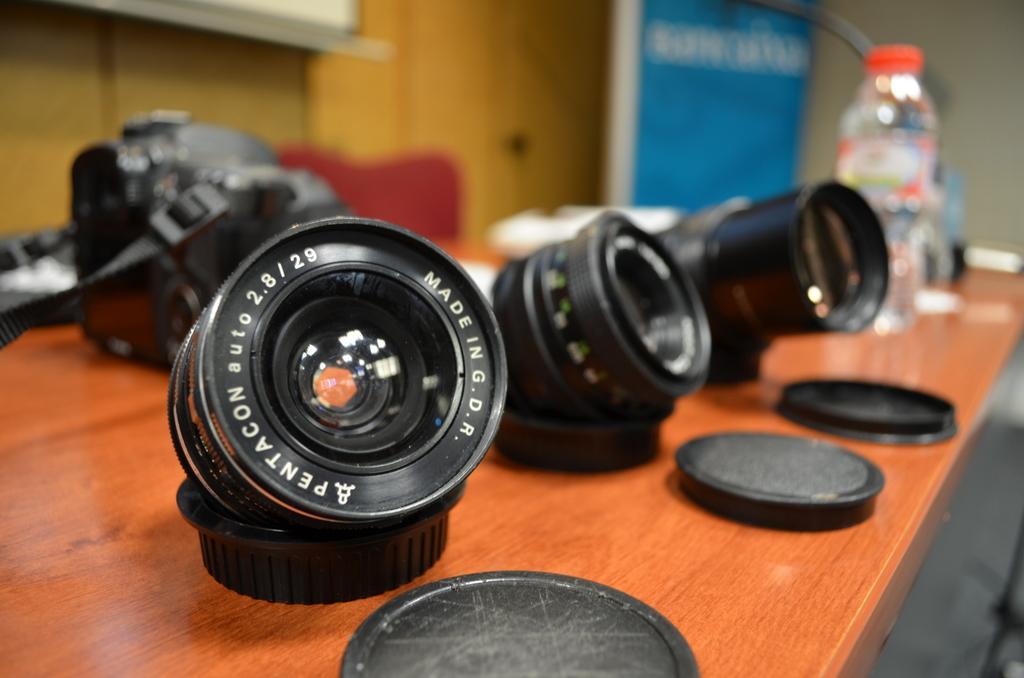Can you describe this image briefly? This image consists of a camera and camera lens kept on a table along with the caps. The table is made up of wood. In the background, we can see a water bottle. On the left, there is a wall. At the bottom, there is a floor. 